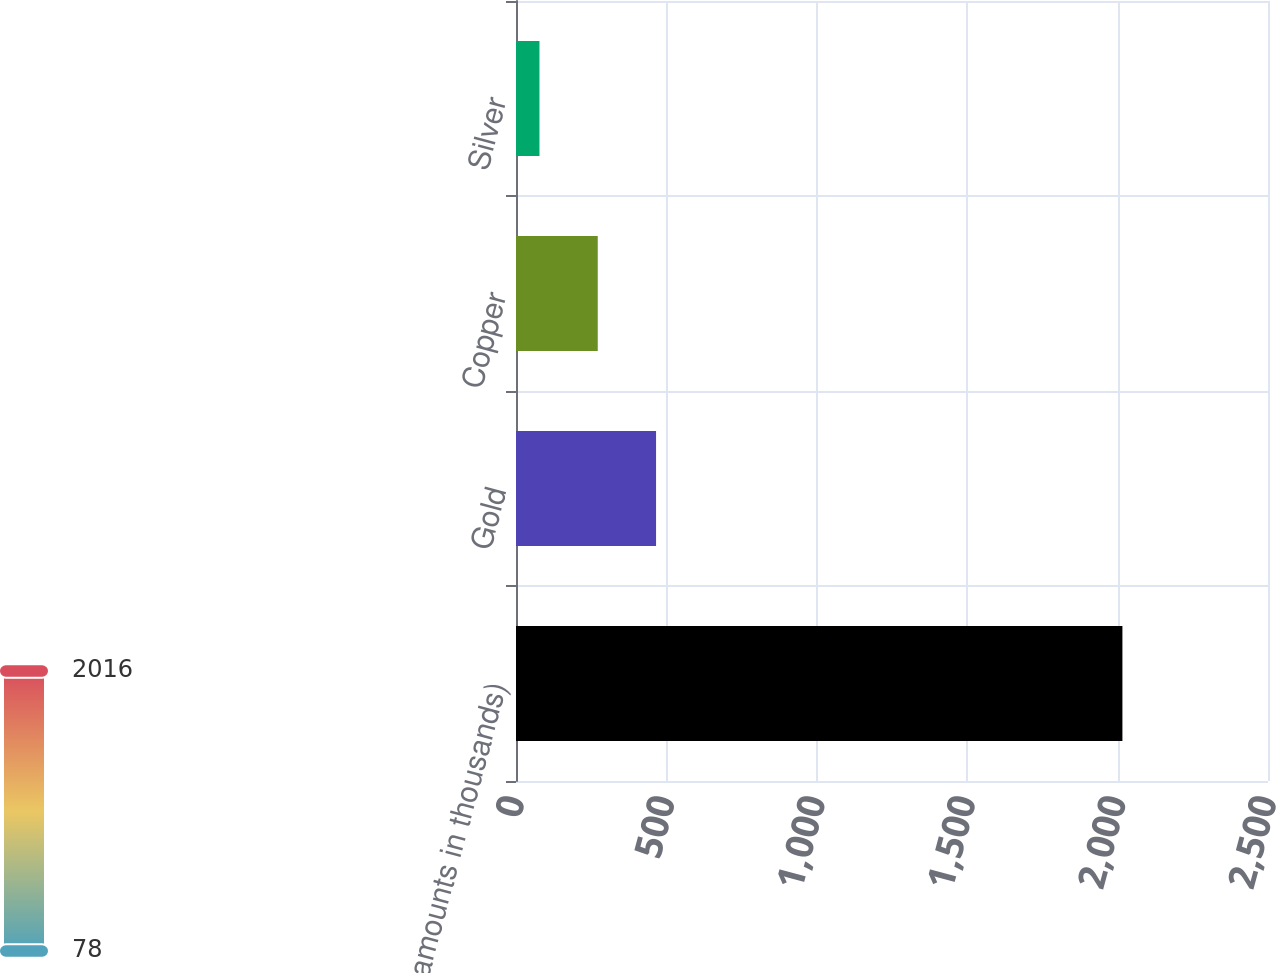Convert chart to OTSL. <chart><loc_0><loc_0><loc_500><loc_500><bar_chart><fcel>(amounts in thousands)<fcel>Gold<fcel>Copper<fcel>Silver<nl><fcel>2016<fcel>465.6<fcel>271.8<fcel>78<nl></chart> 